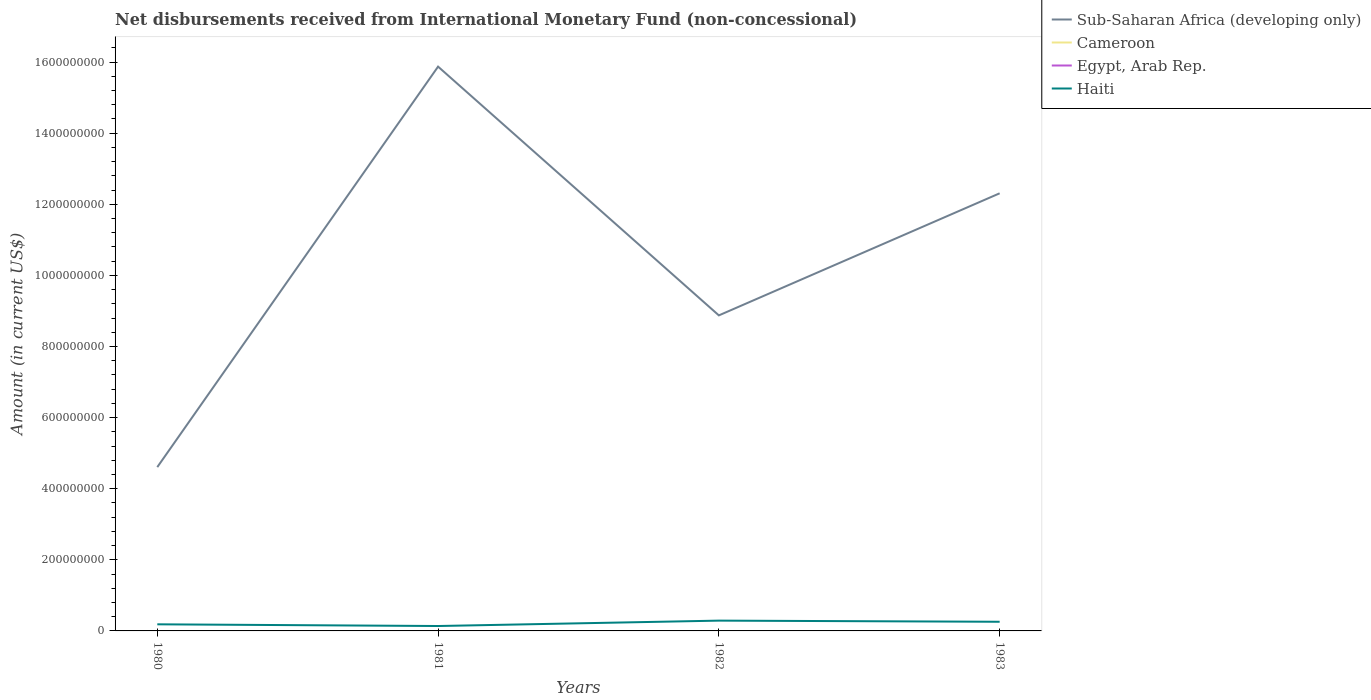How many different coloured lines are there?
Your response must be concise. 2. Across all years, what is the maximum amount of disbursements received from International Monetary Fund in Cameroon?
Make the answer very short. 0. What is the total amount of disbursements received from International Monetary Fund in Haiti in the graph?
Make the answer very short. 4.82e+06. What is the difference between the highest and the second highest amount of disbursements received from International Monetary Fund in Sub-Saharan Africa (developing only)?
Provide a short and direct response. 1.13e+09. How many years are there in the graph?
Your answer should be compact. 4. What is the difference between two consecutive major ticks on the Y-axis?
Your response must be concise. 2.00e+08. Does the graph contain any zero values?
Provide a short and direct response. Yes. How are the legend labels stacked?
Ensure brevity in your answer.  Vertical. What is the title of the graph?
Offer a terse response. Net disbursements received from International Monetary Fund (non-concessional). Does "South Asia" appear as one of the legend labels in the graph?
Provide a succinct answer. No. What is the label or title of the X-axis?
Your response must be concise. Years. What is the label or title of the Y-axis?
Provide a succinct answer. Amount (in current US$). What is the Amount (in current US$) in Sub-Saharan Africa (developing only) in 1980?
Offer a terse response. 4.61e+08. What is the Amount (in current US$) in Cameroon in 1980?
Keep it short and to the point. 0. What is the Amount (in current US$) in Egypt, Arab Rep. in 1980?
Provide a succinct answer. 0. What is the Amount (in current US$) of Haiti in 1980?
Offer a terse response. 1.86e+07. What is the Amount (in current US$) of Sub-Saharan Africa (developing only) in 1981?
Make the answer very short. 1.59e+09. What is the Amount (in current US$) of Haiti in 1981?
Ensure brevity in your answer.  1.38e+07. What is the Amount (in current US$) of Sub-Saharan Africa (developing only) in 1982?
Provide a short and direct response. 8.88e+08. What is the Amount (in current US$) in Cameroon in 1982?
Your response must be concise. 0. What is the Amount (in current US$) of Egypt, Arab Rep. in 1982?
Ensure brevity in your answer.  0. What is the Amount (in current US$) in Haiti in 1982?
Your answer should be compact. 2.90e+07. What is the Amount (in current US$) in Sub-Saharan Africa (developing only) in 1983?
Give a very brief answer. 1.23e+09. What is the Amount (in current US$) of Haiti in 1983?
Ensure brevity in your answer.  2.58e+07. Across all years, what is the maximum Amount (in current US$) of Sub-Saharan Africa (developing only)?
Your answer should be compact. 1.59e+09. Across all years, what is the maximum Amount (in current US$) in Haiti?
Ensure brevity in your answer.  2.90e+07. Across all years, what is the minimum Amount (in current US$) of Sub-Saharan Africa (developing only)?
Offer a terse response. 4.61e+08. Across all years, what is the minimum Amount (in current US$) in Haiti?
Give a very brief answer. 1.38e+07. What is the total Amount (in current US$) of Sub-Saharan Africa (developing only) in the graph?
Your answer should be very brief. 4.17e+09. What is the total Amount (in current US$) in Egypt, Arab Rep. in the graph?
Ensure brevity in your answer.  0. What is the total Amount (in current US$) of Haiti in the graph?
Your response must be concise. 8.71e+07. What is the difference between the Amount (in current US$) in Sub-Saharan Africa (developing only) in 1980 and that in 1981?
Ensure brevity in your answer.  -1.13e+09. What is the difference between the Amount (in current US$) in Haiti in 1980 and that in 1981?
Your answer should be very brief. 4.82e+06. What is the difference between the Amount (in current US$) in Sub-Saharan Africa (developing only) in 1980 and that in 1982?
Offer a terse response. -4.27e+08. What is the difference between the Amount (in current US$) in Haiti in 1980 and that in 1982?
Ensure brevity in your answer.  -1.04e+07. What is the difference between the Amount (in current US$) of Sub-Saharan Africa (developing only) in 1980 and that in 1983?
Give a very brief answer. -7.70e+08. What is the difference between the Amount (in current US$) in Haiti in 1980 and that in 1983?
Your answer should be very brief. -7.17e+06. What is the difference between the Amount (in current US$) in Sub-Saharan Africa (developing only) in 1981 and that in 1982?
Provide a succinct answer. 7.00e+08. What is the difference between the Amount (in current US$) in Haiti in 1981 and that in 1982?
Provide a short and direct response. -1.52e+07. What is the difference between the Amount (in current US$) of Sub-Saharan Africa (developing only) in 1981 and that in 1983?
Your answer should be compact. 3.56e+08. What is the difference between the Amount (in current US$) of Haiti in 1981 and that in 1983?
Your answer should be compact. -1.20e+07. What is the difference between the Amount (in current US$) of Sub-Saharan Africa (developing only) in 1982 and that in 1983?
Provide a succinct answer. -3.43e+08. What is the difference between the Amount (in current US$) of Haiti in 1982 and that in 1983?
Offer a very short reply. 3.20e+06. What is the difference between the Amount (in current US$) of Sub-Saharan Africa (developing only) in 1980 and the Amount (in current US$) of Haiti in 1981?
Offer a terse response. 4.47e+08. What is the difference between the Amount (in current US$) of Sub-Saharan Africa (developing only) in 1980 and the Amount (in current US$) of Haiti in 1982?
Ensure brevity in your answer.  4.32e+08. What is the difference between the Amount (in current US$) of Sub-Saharan Africa (developing only) in 1980 and the Amount (in current US$) of Haiti in 1983?
Your response must be concise. 4.35e+08. What is the difference between the Amount (in current US$) in Sub-Saharan Africa (developing only) in 1981 and the Amount (in current US$) in Haiti in 1982?
Keep it short and to the point. 1.56e+09. What is the difference between the Amount (in current US$) in Sub-Saharan Africa (developing only) in 1981 and the Amount (in current US$) in Haiti in 1983?
Your answer should be very brief. 1.56e+09. What is the difference between the Amount (in current US$) in Sub-Saharan Africa (developing only) in 1982 and the Amount (in current US$) in Haiti in 1983?
Your response must be concise. 8.62e+08. What is the average Amount (in current US$) in Sub-Saharan Africa (developing only) per year?
Your answer should be very brief. 1.04e+09. What is the average Amount (in current US$) in Cameroon per year?
Provide a succinct answer. 0. What is the average Amount (in current US$) of Egypt, Arab Rep. per year?
Ensure brevity in your answer.  0. What is the average Amount (in current US$) of Haiti per year?
Offer a very short reply. 2.18e+07. In the year 1980, what is the difference between the Amount (in current US$) of Sub-Saharan Africa (developing only) and Amount (in current US$) of Haiti?
Your answer should be very brief. 4.42e+08. In the year 1981, what is the difference between the Amount (in current US$) in Sub-Saharan Africa (developing only) and Amount (in current US$) in Haiti?
Give a very brief answer. 1.57e+09. In the year 1982, what is the difference between the Amount (in current US$) of Sub-Saharan Africa (developing only) and Amount (in current US$) of Haiti?
Offer a very short reply. 8.59e+08. In the year 1983, what is the difference between the Amount (in current US$) in Sub-Saharan Africa (developing only) and Amount (in current US$) in Haiti?
Your response must be concise. 1.21e+09. What is the ratio of the Amount (in current US$) of Sub-Saharan Africa (developing only) in 1980 to that in 1981?
Provide a short and direct response. 0.29. What is the ratio of the Amount (in current US$) in Haiti in 1980 to that in 1981?
Provide a succinct answer. 1.35. What is the ratio of the Amount (in current US$) in Sub-Saharan Africa (developing only) in 1980 to that in 1982?
Ensure brevity in your answer.  0.52. What is the ratio of the Amount (in current US$) in Haiti in 1980 to that in 1982?
Your answer should be compact. 0.64. What is the ratio of the Amount (in current US$) of Sub-Saharan Africa (developing only) in 1980 to that in 1983?
Offer a terse response. 0.37. What is the ratio of the Amount (in current US$) of Haiti in 1980 to that in 1983?
Keep it short and to the point. 0.72. What is the ratio of the Amount (in current US$) in Sub-Saharan Africa (developing only) in 1981 to that in 1982?
Make the answer very short. 1.79. What is the ratio of the Amount (in current US$) of Haiti in 1981 to that in 1982?
Your answer should be compact. 0.48. What is the ratio of the Amount (in current US$) in Sub-Saharan Africa (developing only) in 1981 to that in 1983?
Your answer should be very brief. 1.29. What is the ratio of the Amount (in current US$) in Haiti in 1981 to that in 1983?
Your answer should be very brief. 0.53. What is the ratio of the Amount (in current US$) of Sub-Saharan Africa (developing only) in 1982 to that in 1983?
Make the answer very short. 0.72. What is the ratio of the Amount (in current US$) in Haiti in 1982 to that in 1983?
Provide a short and direct response. 1.12. What is the difference between the highest and the second highest Amount (in current US$) in Sub-Saharan Africa (developing only)?
Your response must be concise. 3.56e+08. What is the difference between the highest and the second highest Amount (in current US$) of Haiti?
Your answer should be compact. 3.20e+06. What is the difference between the highest and the lowest Amount (in current US$) in Sub-Saharan Africa (developing only)?
Make the answer very short. 1.13e+09. What is the difference between the highest and the lowest Amount (in current US$) in Haiti?
Your answer should be compact. 1.52e+07. 